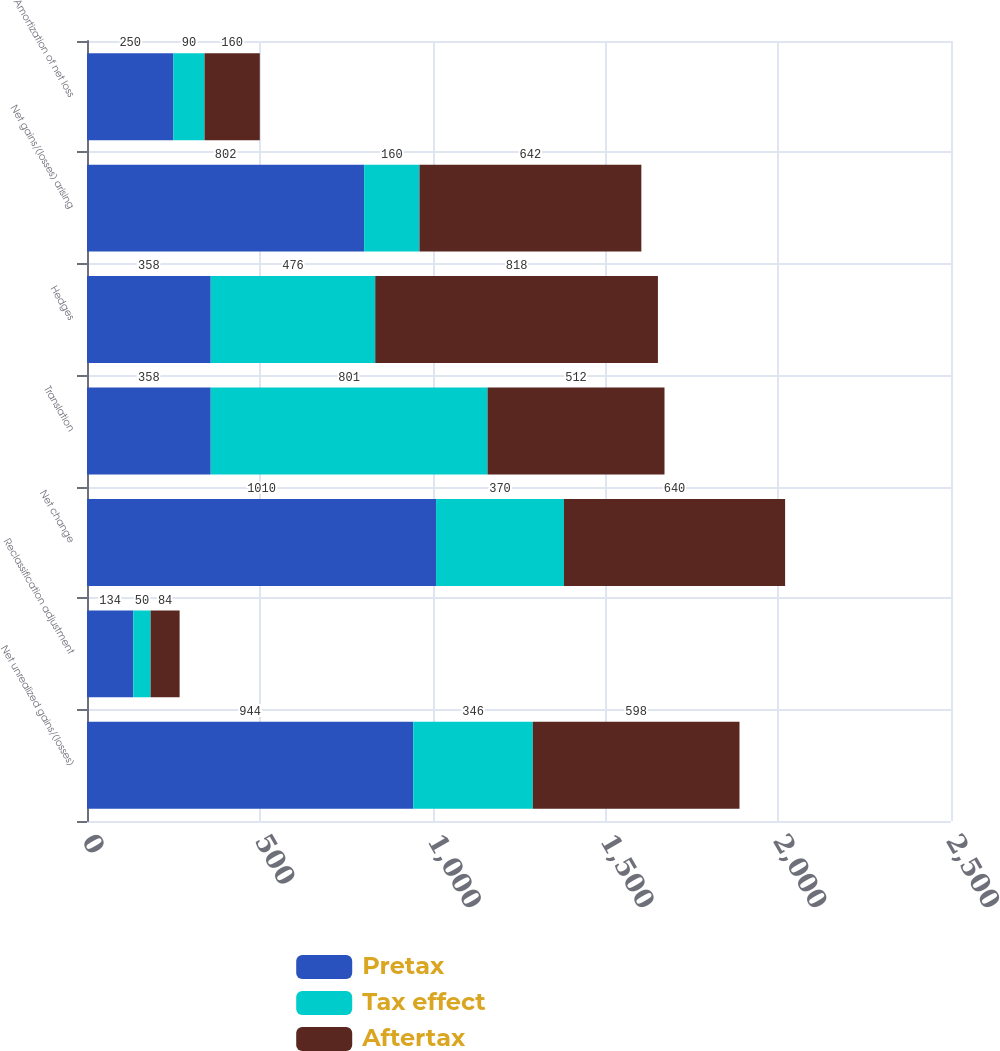Convert chart to OTSL. <chart><loc_0><loc_0><loc_500><loc_500><stacked_bar_chart><ecel><fcel>Net unrealized gains/(losses)<fcel>Reclassification adjustment<fcel>Net change<fcel>Translation<fcel>Hedges<fcel>Net gains/(losses) arising<fcel>Amortization of net loss<nl><fcel>Pretax<fcel>944<fcel>134<fcel>1010<fcel>358<fcel>358<fcel>802<fcel>250<nl><fcel>Tax effect<fcel>346<fcel>50<fcel>370<fcel>801<fcel>476<fcel>160<fcel>90<nl><fcel>Aftertax<fcel>598<fcel>84<fcel>640<fcel>512<fcel>818<fcel>642<fcel>160<nl></chart> 